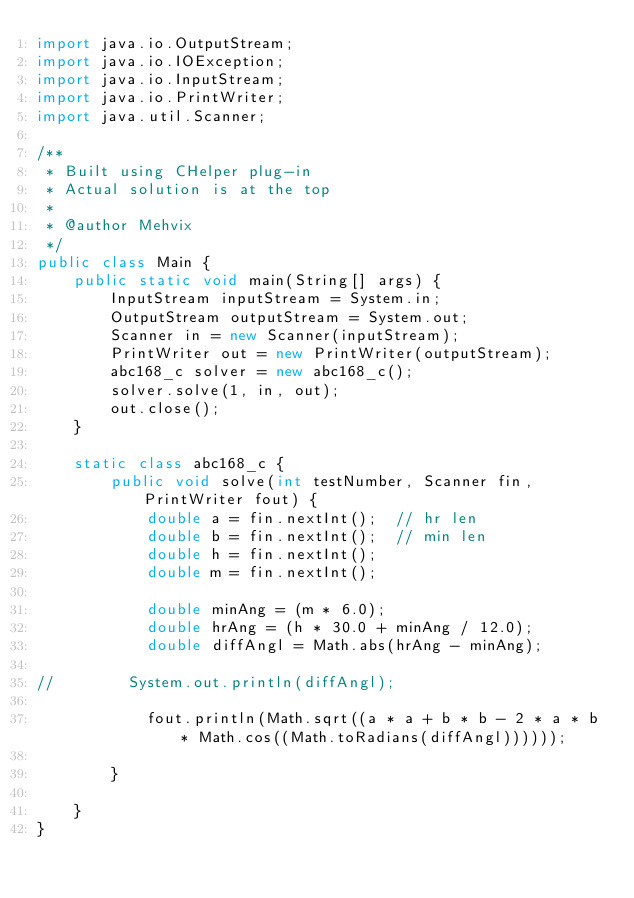<code> <loc_0><loc_0><loc_500><loc_500><_Java_>import java.io.OutputStream;
import java.io.IOException;
import java.io.InputStream;
import java.io.PrintWriter;
import java.util.Scanner;

/**
 * Built using CHelper plug-in
 * Actual solution is at the top
 *
 * @author Mehvix
 */
public class Main {
    public static void main(String[] args) {
        InputStream inputStream = System.in;
        OutputStream outputStream = System.out;
        Scanner in = new Scanner(inputStream);
        PrintWriter out = new PrintWriter(outputStream);
        abc168_c solver = new abc168_c();
        solver.solve(1, in, out);
        out.close();
    }

    static class abc168_c {
        public void solve(int testNumber, Scanner fin, PrintWriter fout) {
            double a = fin.nextInt();  // hr len
            double b = fin.nextInt();  // min len
            double h = fin.nextInt();
            double m = fin.nextInt();

            double minAng = (m * 6.0);
            double hrAng = (h * 30.0 + minAng / 12.0);
            double diffAngl = Math.abs(hrAng - minAng);

//        System.out.println(diffAngl);

            fout.println(Math.sqrt((a * a + b * b - 2 * a * b * Math.cos((Math.toRadians(diffAngl))))));

        }

    }
}

</code> 